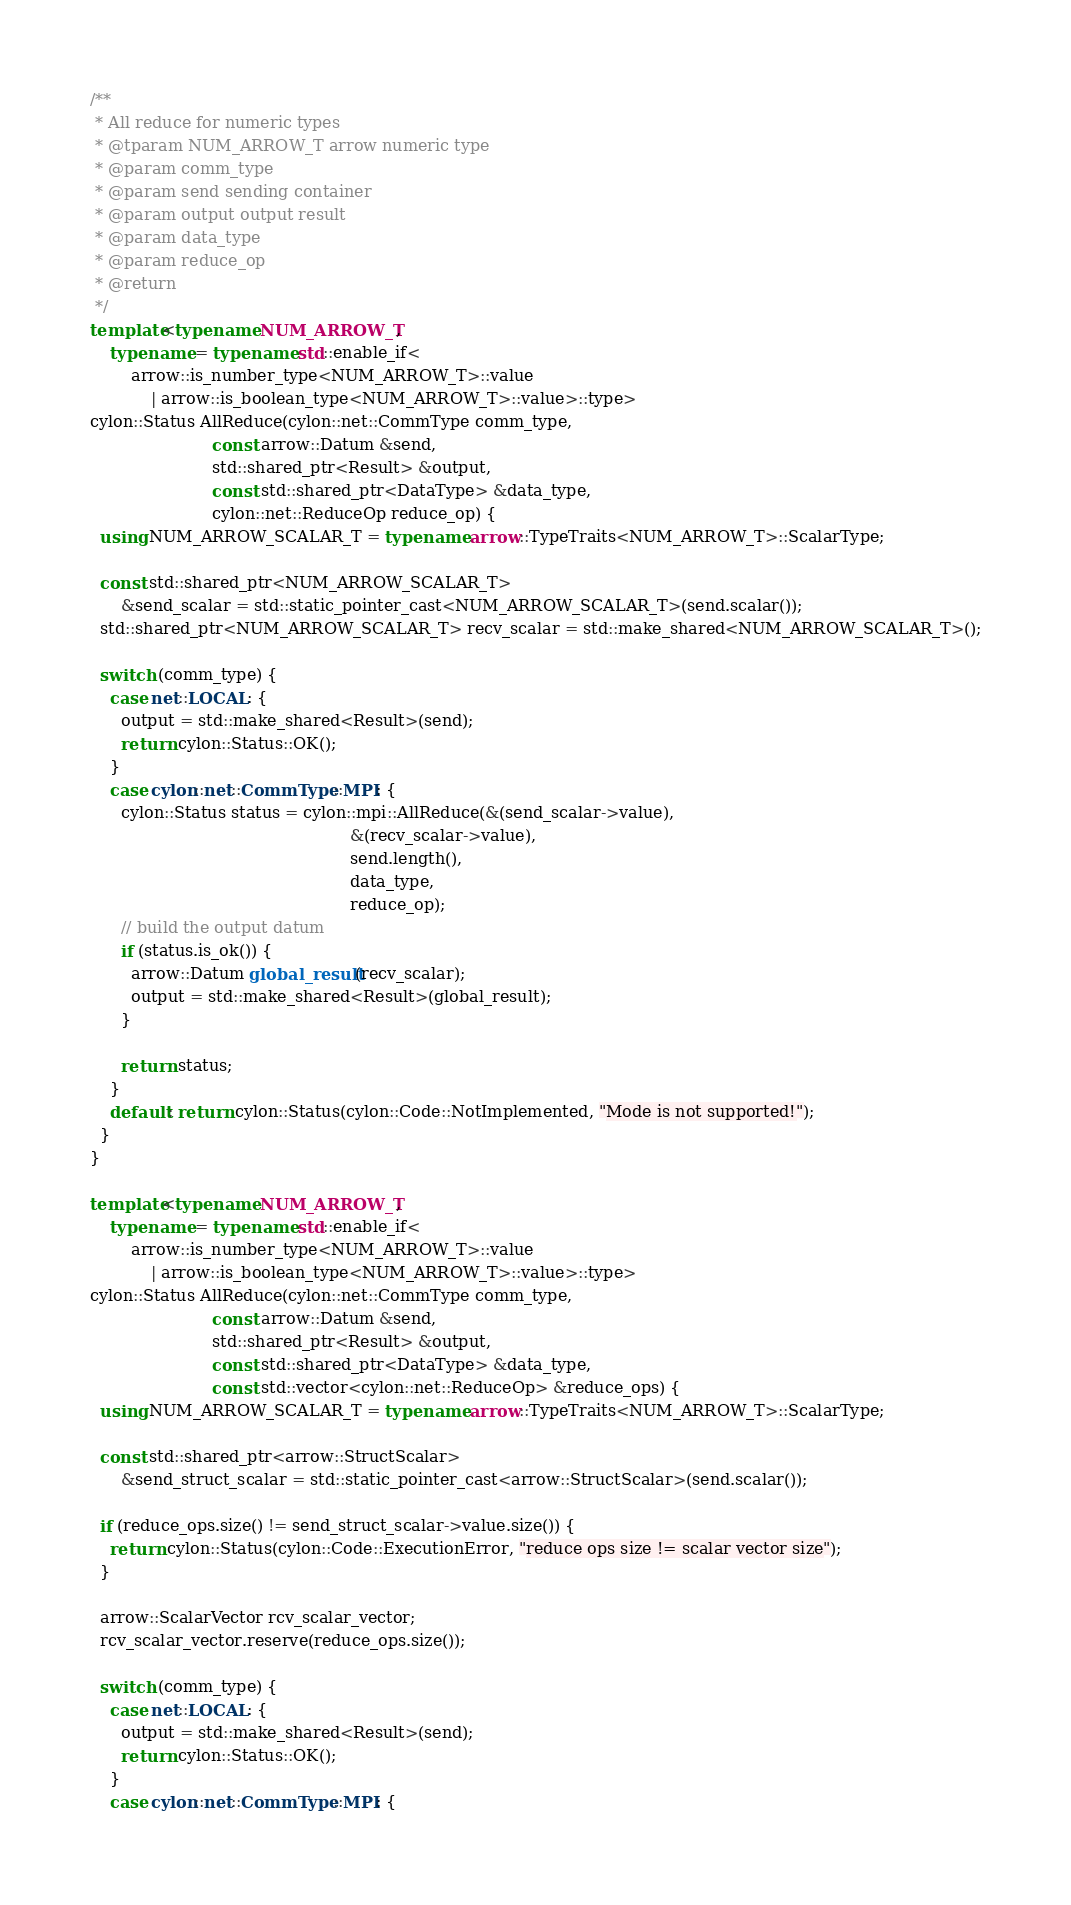<code> <loc_0><loc_0><loc_500><loc_500><_C++_>
/**
 * All reduce for numeric types
 * @tparam NUM_ARROW_T arrow numeric type
 * @param comm_type
 * @param send sending container
 * @param output output result
 * @param data_type
 * @param reduce_op
 * @return
 */
template<typename NUM_ARROW_T,
    typename = typename std::enable_if<
        arrow::is_number_type<NUM_ARROW_T>::value
            | arrow::is_boolean_type<NUM_ARROW_T>::value>::type>
cylon::Status AllReduce(cylon::net::CommType comm_type,
                        const arrow::Datum &send,
                        std::shared_ptr<Result> &output,
                        const std::shared_ptr<DataType> &data_type,
                        cylon::net::ReduceOp reduce_op) {
  using NUM_ARROW_SCALAR_T = typename arrow::TypeTraits<NUM_ARROW_T>::ScalarType;

  const std::shared_ptr<NUM_ARROW_SCALAR_T>
      &send_scalar = std::static_pointer_cast<NUM_ARROW_SCALAR_T>(send.scalar());
  std::shared_ptr<NUM_ARROW_SCALAR_T> recv_scalar = std::make_shared<NUM_ARROW_SCALAR_T>();

  switch (comm_type) {
    case net::LOCAL: {
      output = std::make_shared<Result>(send);
      return cylon::Status::OK();
    }
    case cylon::net::CommType::MPI: {
      cylon::Status status = cylon::mpi::AllReduce(&(send_scalar->value),
                                                   &(recv_scalar->value),
                                                   send.length(),
                                                   data_type,
                                                   reduce_op);
      // build the output datum
      if (status.is_ok()) {
        arrow::Datum global_result(recv_scalar);
        output = std::make_shared<Result>(global_result);
      }

      return status;
    }
    default: return cylon::Status(cylon::Code::NotImplemented, "Mode is not supported!");
  }
}

template<typename NUM_ARROW_T,
    typename = typename std::enable_if<
        arrow::is_number_type<NUM_ARROW_T>::value
            | arrow::is_boolean_type<NUM_ARROW_T>::value>::type>
cylon::Status AllReduce(cylon::net::CommType comm_type,
                        const arrow::Datum &send,
                        std::shared_ptr<Result> &output,
                        const std::shared_ptr<DataType> &data_type,
                        const std::vector<cylon::net::ReduceOp> &reduce_ops) {
  using NUM_ARROW_SCALAR_T = typename arrow::TypeTraits<NUM_ARROW_T>::ScalarType;

  const std::shared_ptr<arrow::StructScalar>
      &send_struct_scalar = std::static_pointer_cast<arrow::StructScalar>(send.scalar());

  if (reduce_ops.size() != send_struct_scalar->value.size()) {
    return cylon::Status(cylon::Code::ExecutionError, "reduce ops size != scalar vector size");
  }

  arrow::ScalarVector rcv_scalar_vector;
  rcv_scalar_vector.reserve(reduce_ops.size());

  switch (comm_type) {
    case net::LOCAL: {
      output = std::make_shared<Result>(send);
      return cylon::Status::OK();
    }
    case cylon::net::CommType::MPI: {</code> 